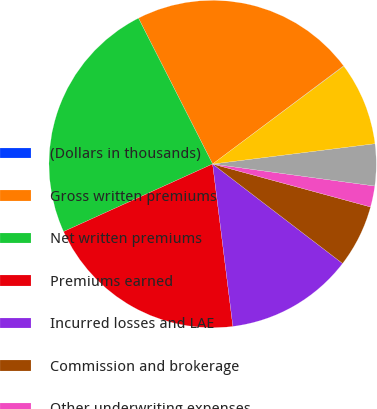Convert chart. <chart><loc_0><loc_0><loc_500><loc_500><pie_chart><fcel>(Dollars in thousands)<fcel>Gross written premiums<fcel>Net written premiums<fcel>Premiums earned<fcel>Incurred losses and LAE<fcel>Commission and brokerage<fcel>Other underwriting expenses<fcel>Underwriting gain (loss)<fcel>Commission and brokerage Other<nl><fcel>0.04%<fcel>22.25%<fcel>24.29%<fcel>20.2%<fcel>12.63%<fcel>6.17%<fcel>2.08%<fcel>4.13%<fcel>8.22%<nl></chart> 